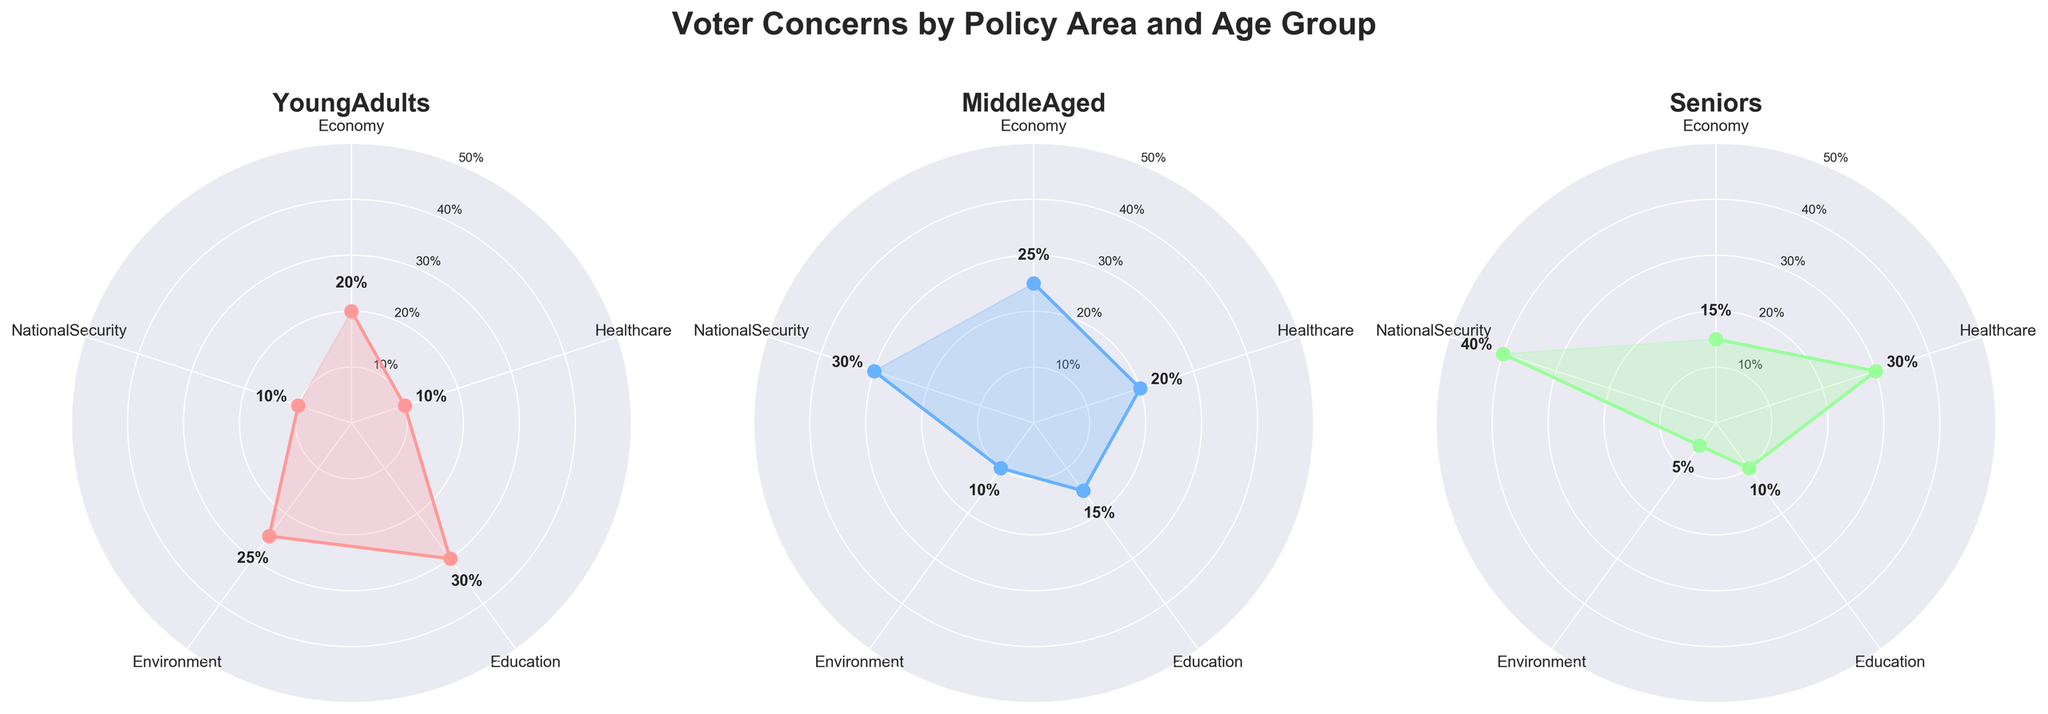What is the title of the figure? The title appears at the top of the figure, with larger and bolded text. It reads "Voter Concerns by Policy Area and Age Group."
Answer: Voter Concerns by Policy Area and Age Group Which age group has the highest concern for National Security? In the subplot representing Seniors, the line corresponding to National Security reaches its highest value.
Answer: Seniors How many age groups are represented in each subplot? Each subplot represents one age group. There are three subplots corresponding to Young Adults, Middle Aged, and Seniors.
Answer: 3 What is the combined percentage concern for Healthcare across all age groups? Sum the percentages for Healthcare in all subplots: 10% (Young Adults) + 20% (Middle Aged) + 30% (Seniors).
Answer: 60% Which policy area shows the highest concern among Young Adults? The values in the Young Adults subplot indicate that Education has a peak value of 30%.
Answer: Education How does the concern for Economy vary among different age groups? In the Young Adults subplot, Economy is at 20%. In the Middle Aged subplot, it rises to 25%. In the Seniors subplot, it decreases to 15%.
Answer: Young Adults: 20%, Middle Aged: 25%, Seniors: 15% What is the lowest concern percentage across all policy areas and age groups? In the Seniors subplot, the value for Environment is the lowest at 5%.
Answer: 5% Compare the concern for Education between Young Adults and Seniors. In the Young Adults subplot, Education has a value of 30%. In the Seniors subplot, it has a value of 10%. The difference is 20%.
Answer: 20% What is the average concern percentage for National Security across all age groups? Sum the percentages for National Security: 10% (Young Adults) + 30% (Middle Aged) + 40% (Seniors) = 80%. Then divide by 3: 80/3 ≈ 26.67%.
Answer: 26.67% Which age group shows the least concern for the Environment? Among all three subplots, the Senior age group's subplot shows the Environment concern at the lowest value of 5%.
Answer: Seniors 